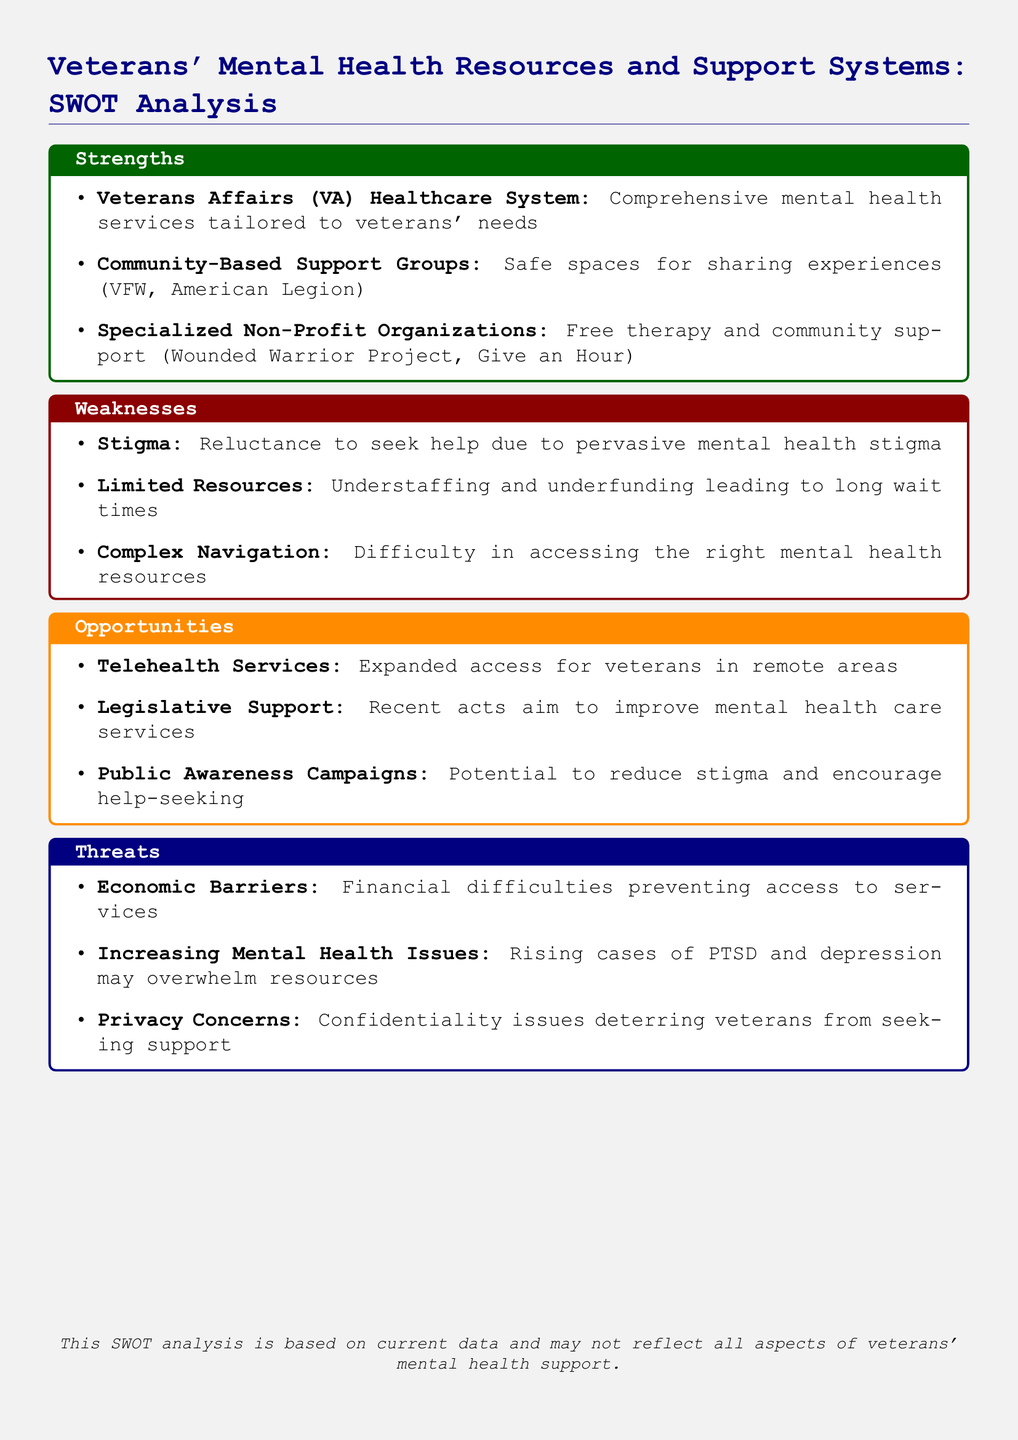What is the title of the document? The title of the document is stated at the top and summarizes the subject matter.
Answer: Veterans' Mental Health Resources and Support Systems: SWOT Analysis What is one strength mentioned in the analysis? The strengths include a variety of support systems available, one of which is specified.
Answer: Veterans Affairs (VA) Healthcare System What is one weakness outlined in the document? The weaknesses section highlights issues that hinder effective mental health care, one of which is specified.
Answer: Stigma What opportunity for veterans' mental health support is identified? The opportunities section discusses future possibilities for improvement, one of which is specified.
Answer: Telehealth Services What is one threat to veterans' mental health resources? The threats identify challenges that could worsen the situation for veterans, one of which is specified.
Answer: Economic Barriers How many main sections are in the SWOT analysis? The document is structured into four key sections: strengths, weaknesses, opportunities, and threats.
Answer: Four Which specialized non-profit organization is mentioned as a resource? This refers to specific organizations that provide support detailed in the strengths section.
Answer: Wounded Warrior Project What is a key legislative opportunity mentioned? This reference addresses recent government actions aimed at supporting mental health for veterans.
Answer: Recent acts What kind of concerns deter veterans from seeking help? This refers to specific barriers that may prevent veterans from utilizing available resources.
Answer: Privacy Concerns 